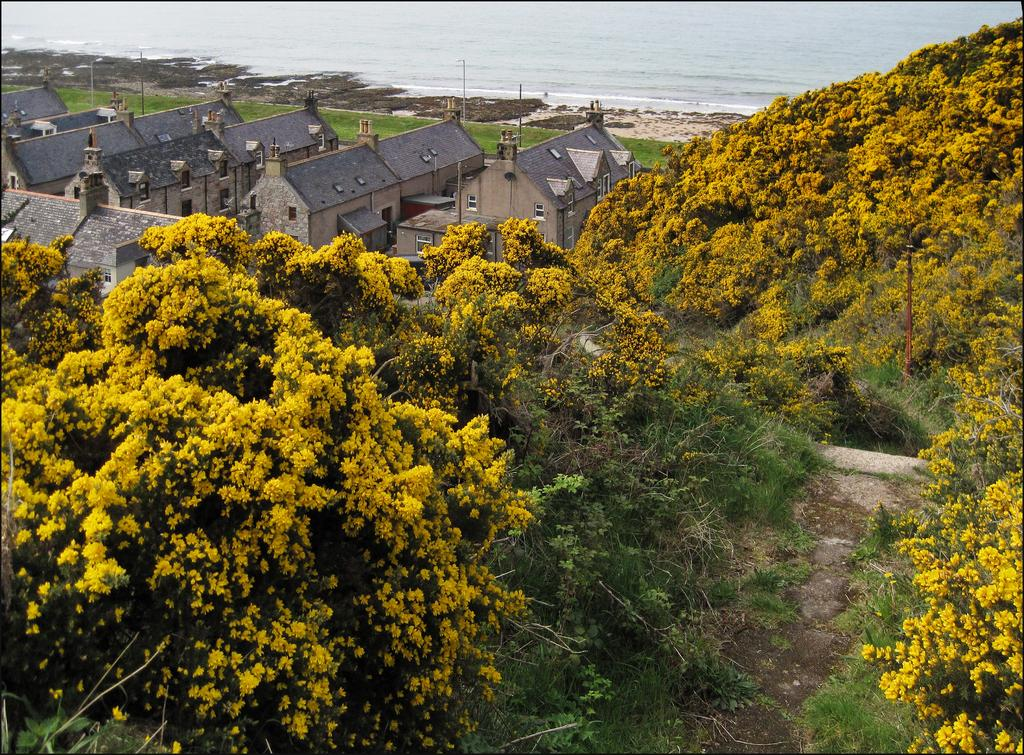What type of vegetation can be seen in the image? There are trees and flowers in the image. What type of ground cover is visible in the image? There is grass visible in the image. What type of natural feature is visible in the image? There is water visible in the image. What type of man-made structures can be seen in the image? There are buildings visible at the top of the image. What type of collar can be seen on the dog in the image? There is no dog present in the image, so there is no collar visible. What type of notebook is being used by the person in the image? There is no person or notebook present in the image. 